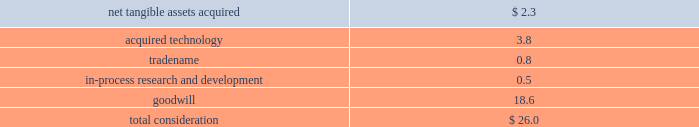Notes to consolidated financial statements ( continued ) note 4 2014acquisitions ( continued ) acquisition of emagic gmbh during the fourth quarter of 2002 , the company acquired emagic gmbh ( emagic ) , a provider of professional software solutions for computer based music production , for approximately $ 30 million in cash ; $ 26 million of which was paid immediately upon closing of the deal and $ 4 million of which was held-back for future payment contingent on continued employment by certain employees that would be allocated to future compensation expense in the appropriate periods over the following 3 years .
During fiscal 2003 , contingent consideration totaling $ 1.3 million was paid .
The acquisition has been accounted for as a purchase .
The portion of the purchase price allocated to purchased in-process research and development ( ipr&d ) was expensed immediately , and the portion of the purchase price allocated to acquired technology and to tradename will be amortized over their estimated useful lives of 3 years .
Goodwill associated with the acquisition of emagic is not subject to amortization pursuant to the provisions of sfas no .
142 .
Total consideration was allocated as follows ( in millions ) : .
The amount of the purchase price allocated to ipr&d was expensed upon acquisition , because the technological feasibility of products under development had not been established and no alternative future uses existed .
The ipr&d relates primarily to emagic 2019s logic series technology and extensions .
At the date of the acquisition , the products under development were between 43%-83% ( 43%-83 % ) complete , and it was expected that the remaining work would be completed during the company 2019s fiscal 2003 at a cost of approximately $ 415000 .
The remaining efforts , which were completed in 2003 , included finalizing user interface design and development , and testing .
The fair value of the ipr&d was determined using an income approach , which reflects the projected free cash flows that will be generated by the ipr&d projects and that are attributable to the acquired technology , and discounting the projected net cash flows back to their present value using a discount rate of 25% ( 25 % ) .
Acquisition of certain assets of zayante , inc. , prismo graphics , and silicon grail during fiscal 2002 the company acquired certain technology and patent rights of zayante , inc. , prismo graphics , and silicon grail corporation for a total of $ 20 million in cash .
These transactions have been accounted for as asset acquisitions .
The purchase price for these asset acquisitions , except for $ 1 million identified as contingent consideration which would be allocated to compensation expense over the following 3 years , has been allocated to acquired technology and would be amortized on a straight-line basis over 3 years , except for certain assets acquired from zayante associated with patent royalty streams that would be amortized over 10 years .
Acquisition of nothing real , llc during the second quarter of 2002 , the company acquired certain assets of nothing real , llc ( nothing real ) , a privately-held company that develops and markets high performance tools designed for the digital image creation market .
Of the $ 15 million purchase price , the company has allocated $ 7 million to acquired technology , which will be amortized over its estimated life of 5 years .
The remaining $ 8 million , which has been identified as contingent consideration , rather than recorded as an additional component of .
What percentage of the purchase price was spent on goodwill? 
Computations: (18.6 / 26.0)
Answer: 0.71538. 